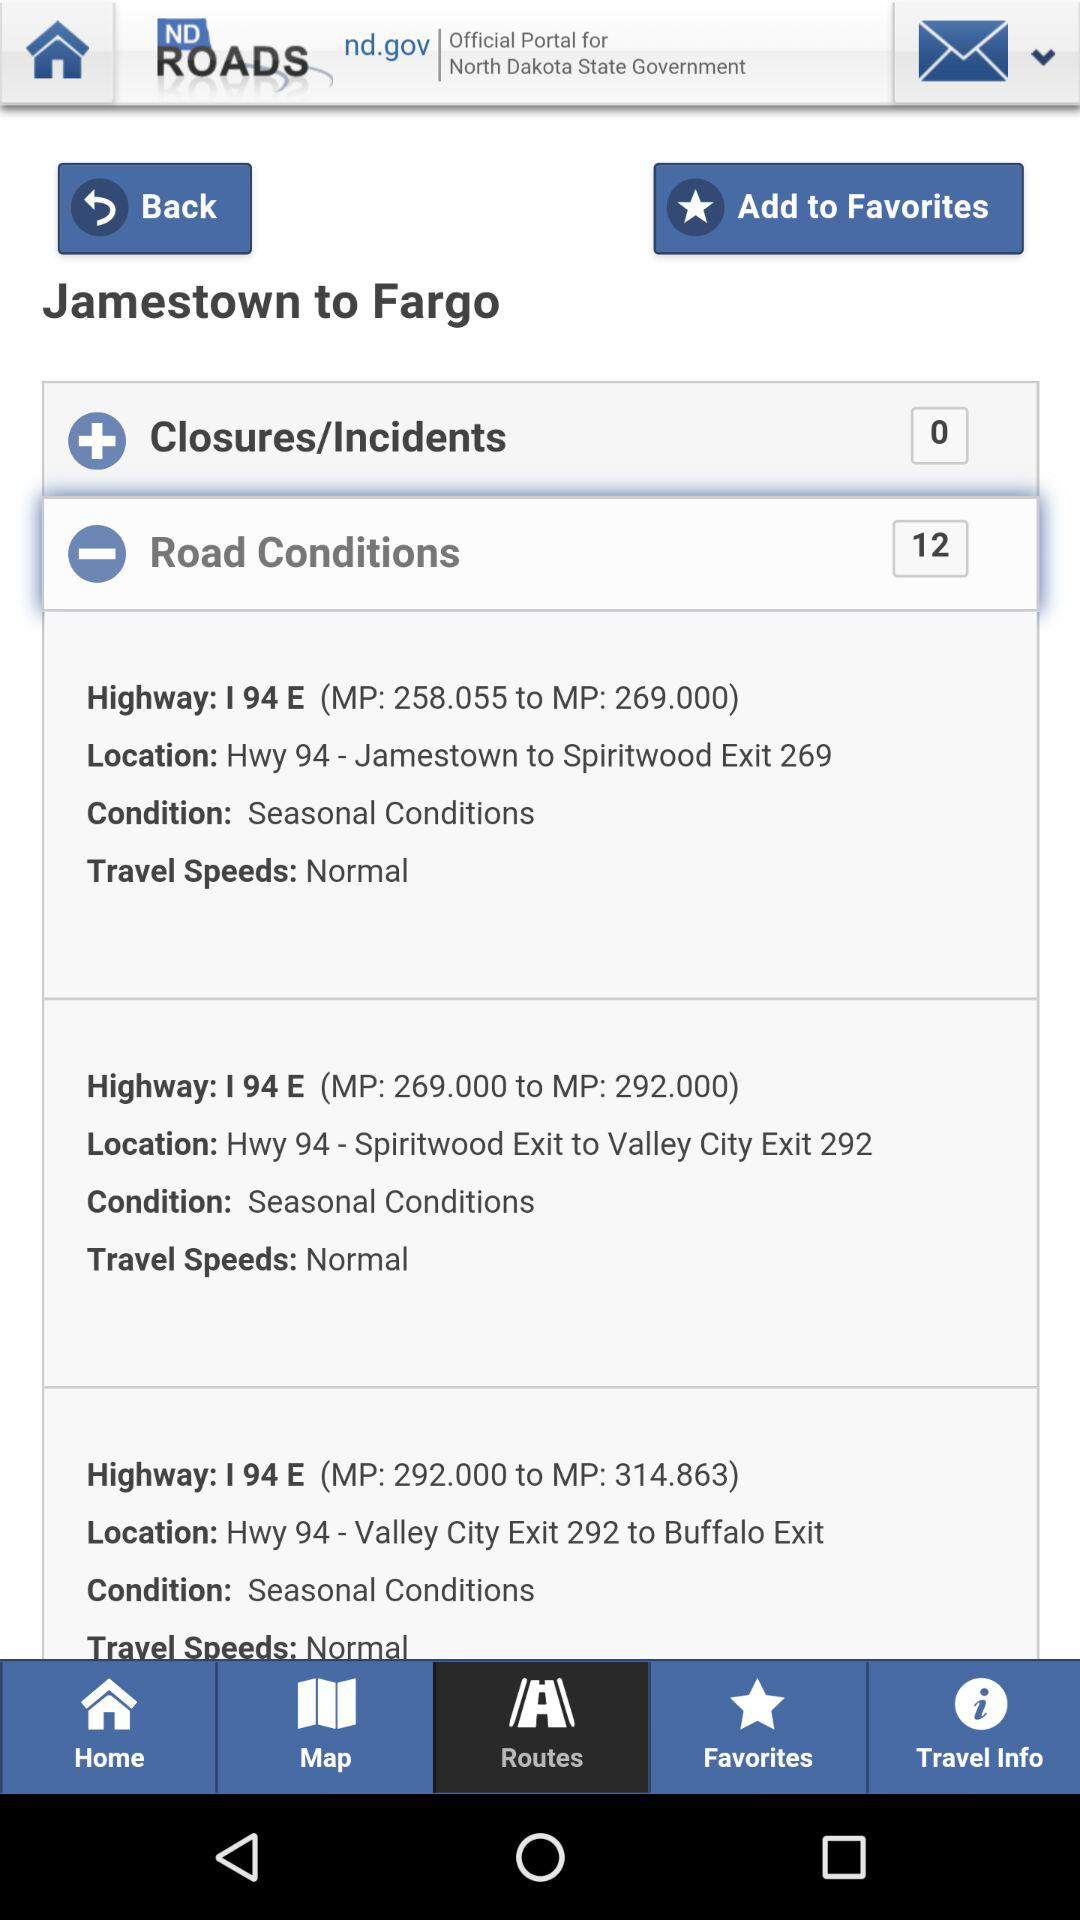Which option is selected? The selected option is "Routes". 